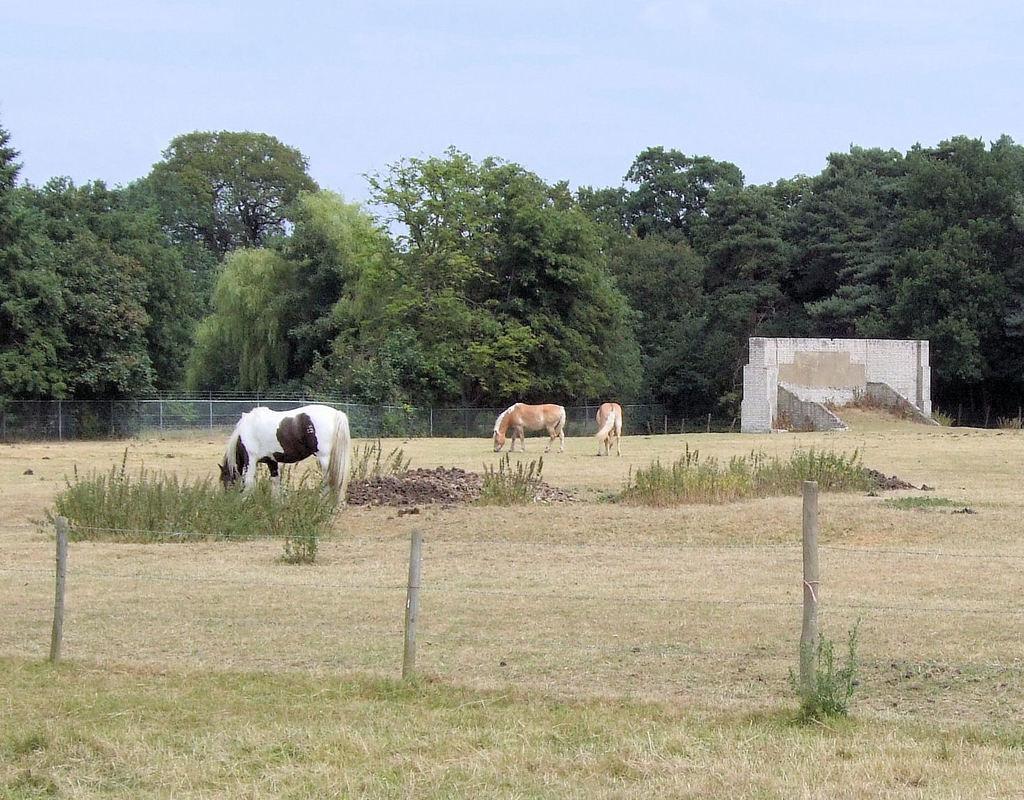Describe this image in one or two sentences. In this image, we can see animals, trees, a fence, poles and a wall. At the bottom, there are some plants on the ground. 